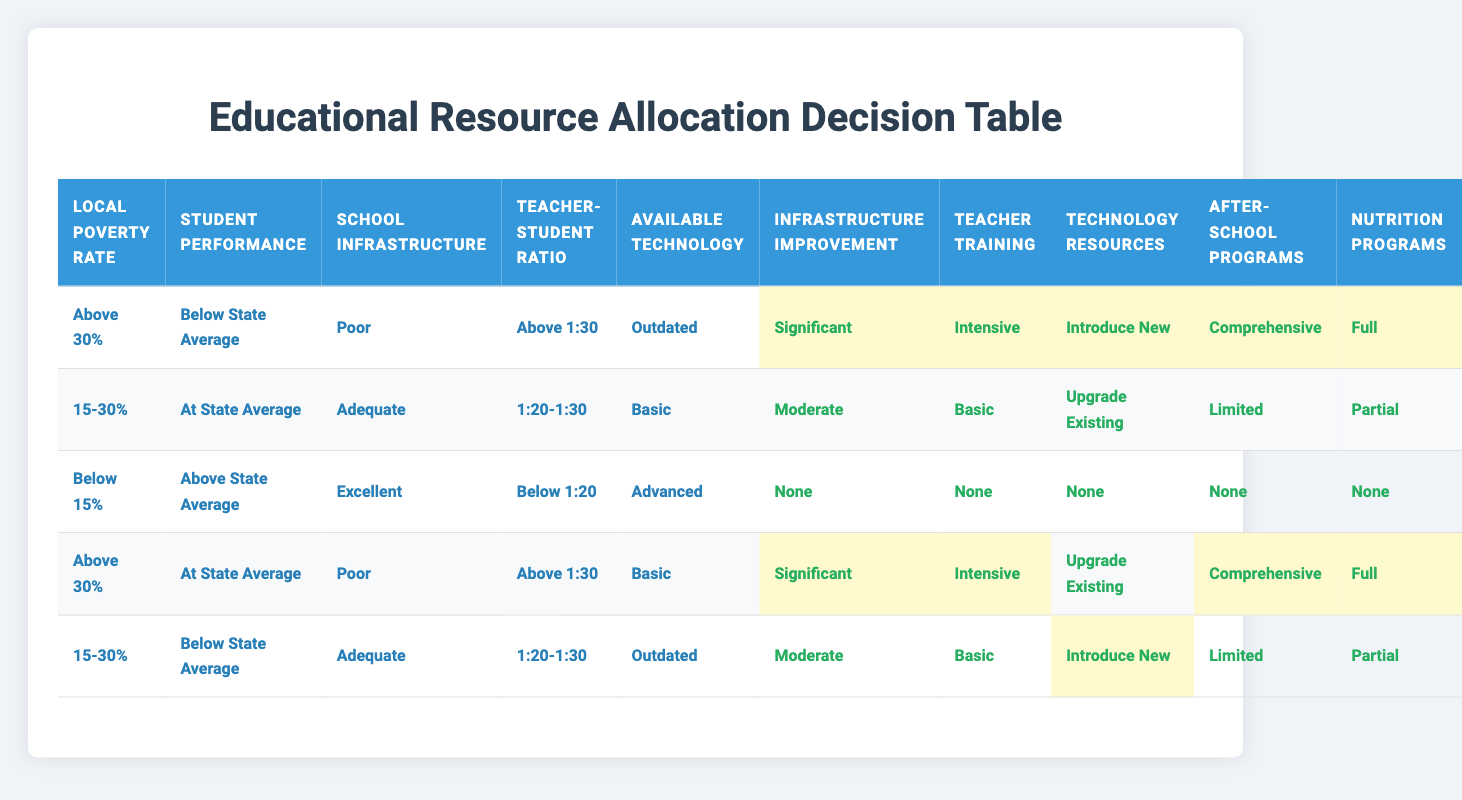What are the allocated actions for a local poverty rate of above 30%, below state average performance, poor infrastructure, a teacher-student ratio above 1:30, and outdated technology? According to the table, for the specified conditions, the actions allocated are significant for infrastructure improvement, intensive for teacher training programs, introduce new technology resources, comprehensive for after-school programs, and full for nutrition programs.
Answer: Significant, Intensive, Introduce New, Comprehensive, Full If a school has adequate infrastructure, is at the state average for student performance, and has a teacher-student ratio of 1:20-1:30, what actions are allocated? The table shows that under these conditions, the actions to be taken are moderate for infrastructure improvement, basic for teacher training programs, upgrade existing technology resources, limited for after-school programs, and partial for nutrition programs.
Answer: Moderate, Basic, Upgrade Existing, Limited, Partial Is there any situation where no actions are allocated? Yes, the table indicates that when the local poverty rate is below 15%, student performance is above state average, school infrastructure is excellent, the ratio is below 1:20, and available technology is advanced, no actions are allocated at all.
Answer: Yes How many actions are highlighted for scenarios involving a local poverty rate above 30%? There are 3 actions highlighted in the first row for the condition where the local poverty rate is above 30% and student performance is below state average. In the fourth row, there are 2 highlighted actions when the performance is at state average. Therefore, totaling 5 highlighted actions.
Answer: 5 For schools with below 15% poverty rate and below 1:20 teacher-student ratio, what actions are allocated if the technology is outdated? Looking at the relevant row in the table, when the poverty rate is below 15%, the teacher-student ratio is below 1:20, and the available technology is outdated, the actions become significant for infrastructure improvement, intensive for teacher training, introduce new for technology resources, comprehensive for after-school programs, and full for nutrition programs.
Answer: Significant, Intensive, Introduce New, Comprehensive, Full What is the difference between actions allocated for a local poverty rate of 15-30% and actions for above 30% while having poor infrastructure? For a poverty rate of 15-30% (row two) with poor infrastructure, the actions are moderate, basic, upgrade existing, limited, and partial. For above 30% with poor infrastructure (row four), the actions become significant, intensive, upgrade existing, comprehensive, and full. Thus, the difference is that the actions allocated for poverty rate above 30% are more intense and substantial.
Answer: The actions for above 30% are significant and intensive compared to moderate and basic for 15-30% How many actions are there for a scenario with a poverty rate of below 15%, above state average performance, and excellent infrastructure? According to the table, there are no actions allocated for this scenario. Therefore, the total number of actions amounts to zero.
Answer: 0 What is the maximum level of actions allocated for "Offer After-School Programs"? The maximum level of allocation for "Offer After-School Programs" is comprehensive, which is allocated in two scenarios: one with above 30% poverty and below state average performance, and the other with above 30% poverty and at state average performance.
Answer: Comprehensive 